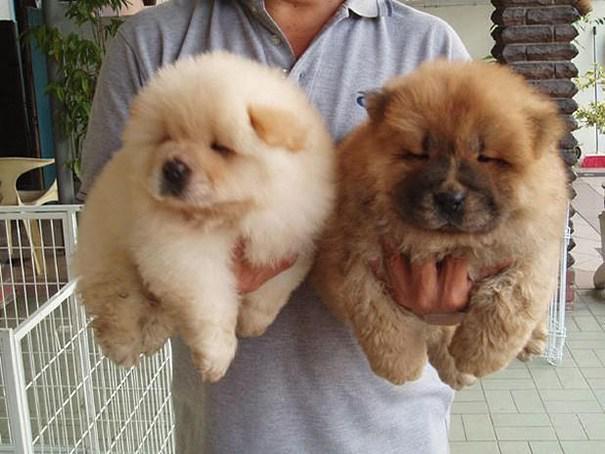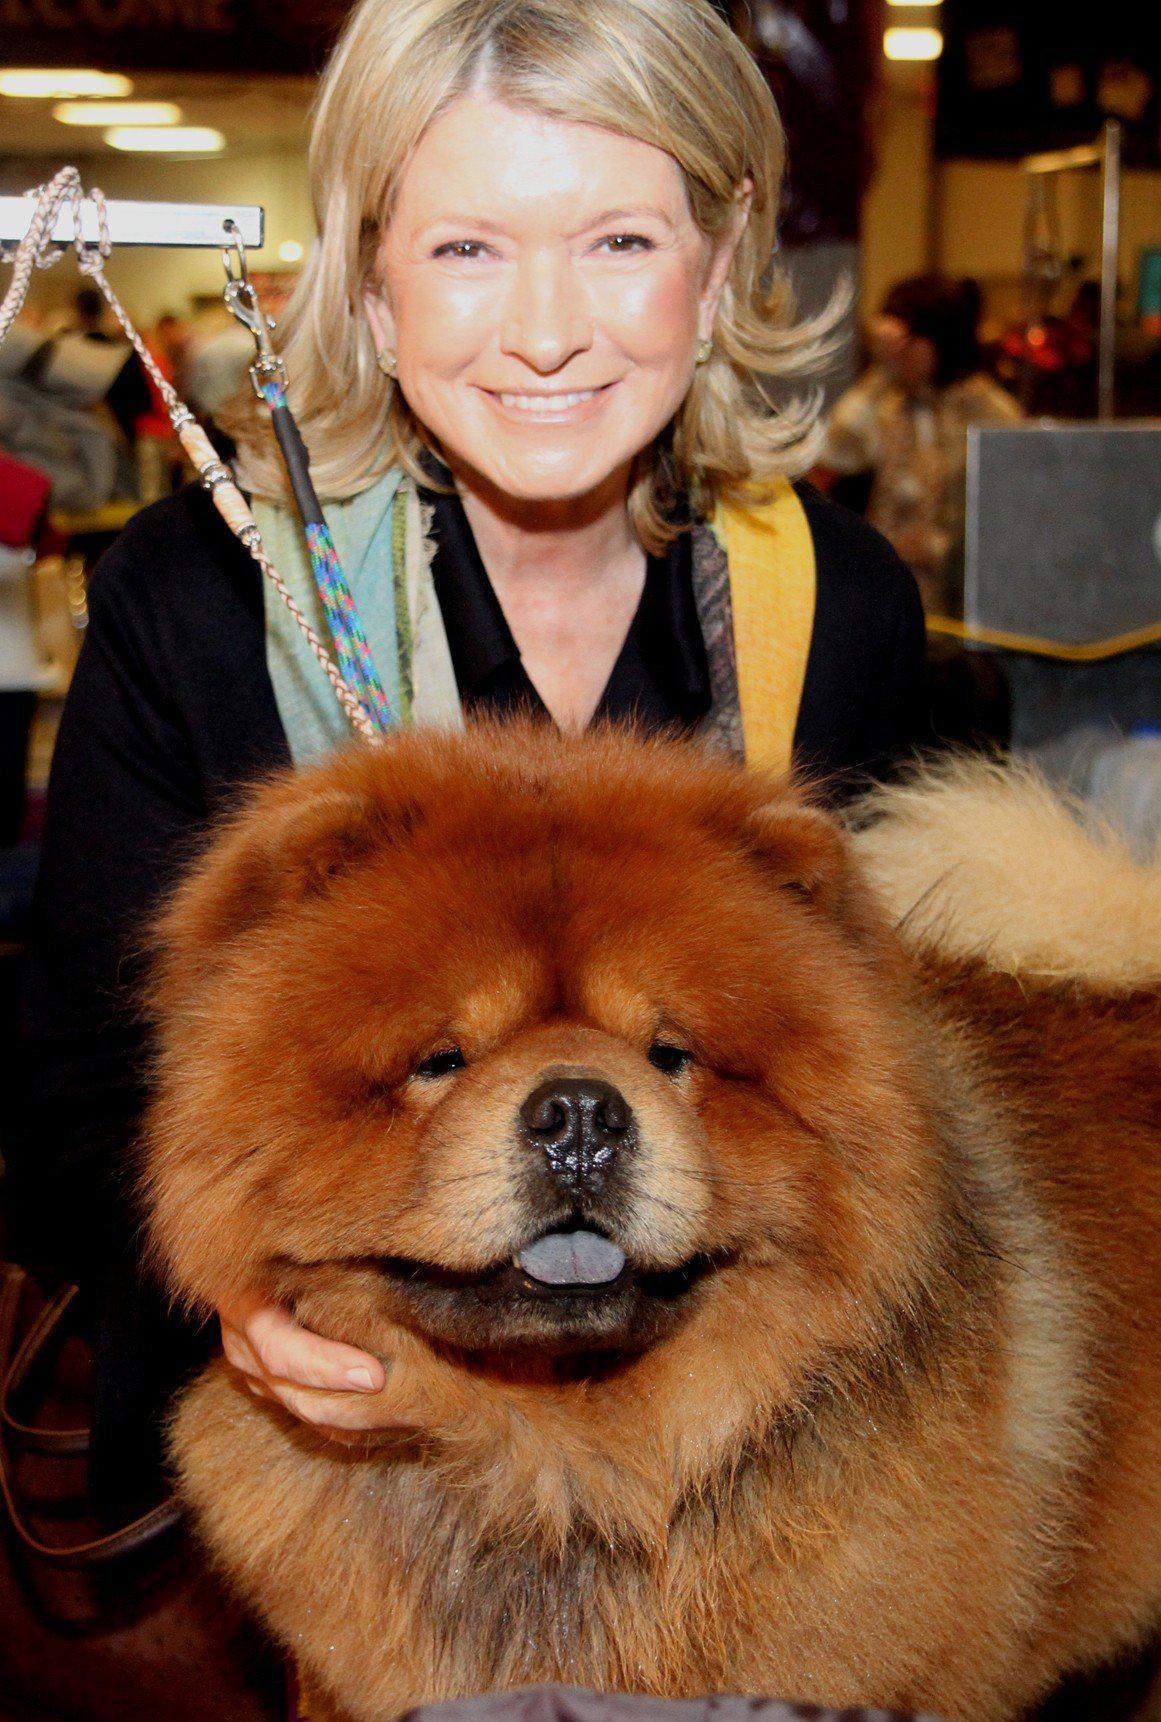The first image is the image on the left, the second image is the image on the right. Given the left and right images, does the statement "A person is holding at least two fluffy Chow Chow puppies in the image on the left." hold true? Answer yes or no. Yes. The first image is the image on the left, the second image is the image on the right. Assess this claim about the two images: "The left image features a person holding at least two chow puppies in front of their chest.". Correct or not? Answer yes or no. Yes. 